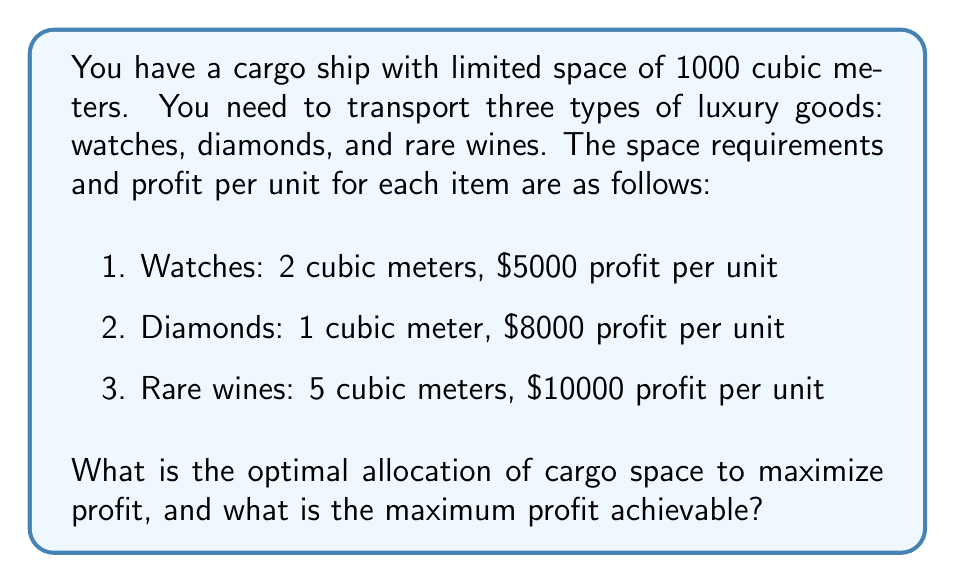Could you help me with this problem? This problem can be solved using linear programming. Let's define our variables:

$x$ = number of watch units
$y$ = number of diamond units
$z$ = number of rare wine units

Our objective function (profit) is:
$$P = 5000x + 8000y + 10000z$$

Subject to the constraints:
1. Space constraint: $2x + y + 5z \leq 1000$
2. Non-negativity: $x, y, z \geq 0$

To solve this, we can use the simplex method or a graphical approach. However, given the integer nature of the units, we can also use a more direct approach:

1. Start by filling the space with the item that has the highest profit per cubic meter:
   Diamonds: $8000/1 = 8000$ $/m^3$
   Watches: $5000/2 = 2500$ $/m^3$
   Wines: $10000/5 = 2000$ $/m^3$

2. Fill the space with diamonds: 1000 units, using 1000 cubic meters.
   Profit: $1000 * 8000 = 8,000,000$

3. However, we need to consider if replacing some diamonds with wines could increase profit:
   Replacing 5 cubic meters of diamonds (5 units) with 1 unit of wine:
   Loss: $5 * 8000 = 40,000$
   Gain: $1 * 10000 = 10,000$
   Net loss: $30,000$

4. Since replacing diamonds with wines decreases profit, and watches have an even lower profit per cubic meter, the optimal solution is to fill the entire cargo with diamonds.
Answer: Optimal allocation: 1000 units of diamonds
Maximum profit: $8,000,000 